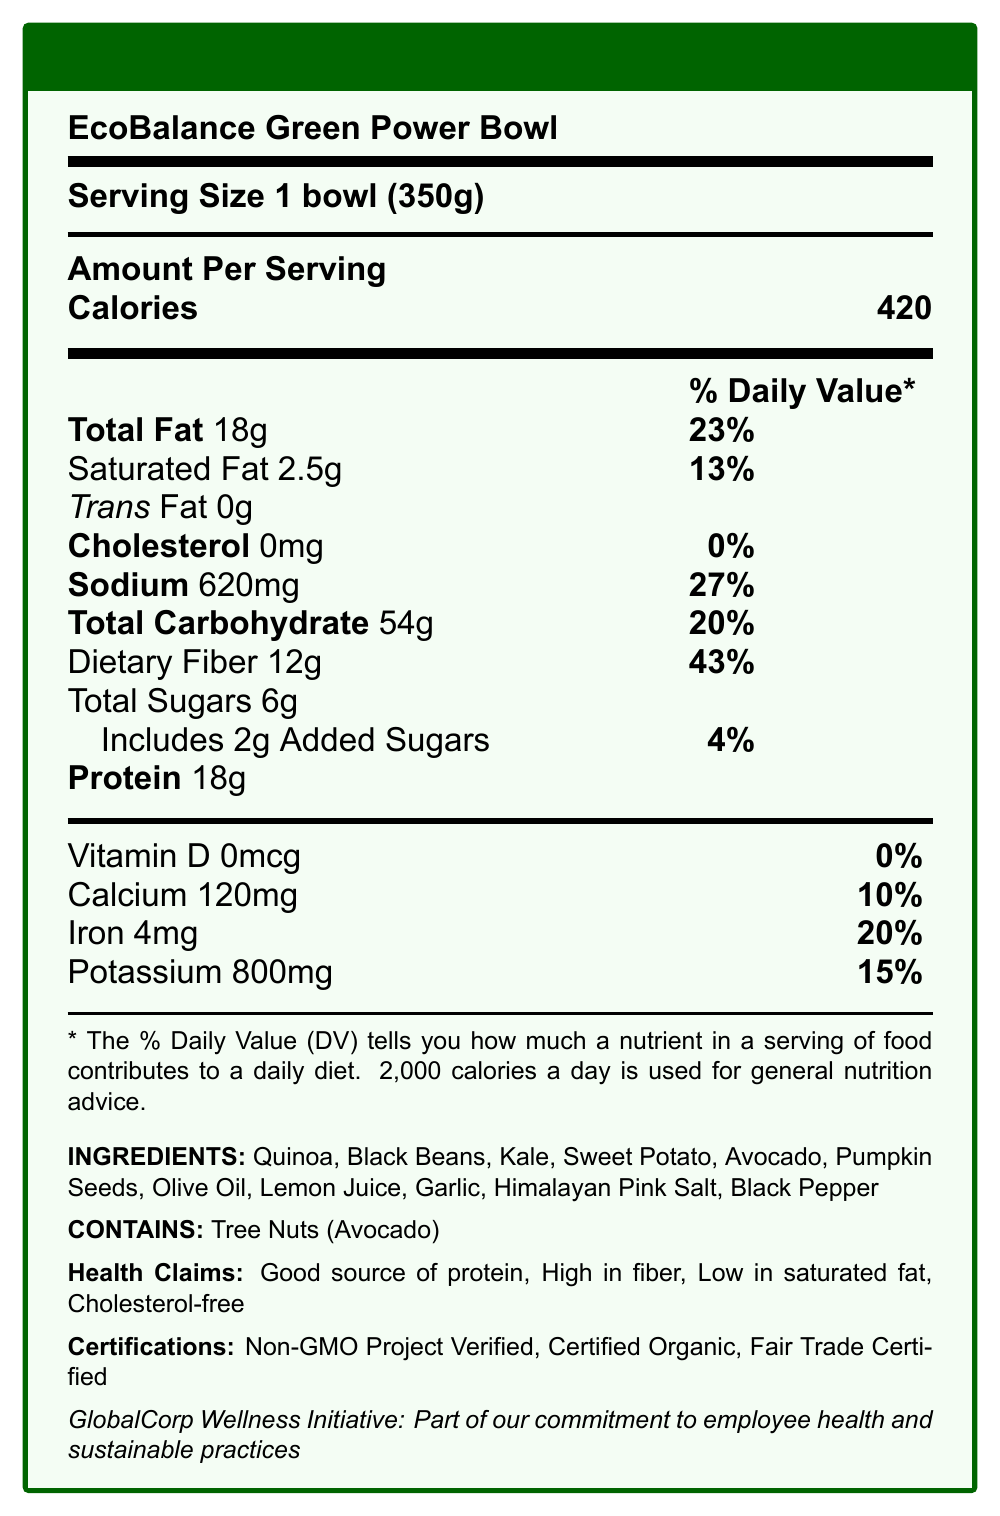what is the serving size for the EcoBalance Green Power Bowl? The serving size is explicitly mentioned as "1 bowl (350g)" in the document.
Answer: 1 bowl (350g) how many calories are there per serving? The document specifies that there are 420 calories per serving.
Answer: 420 calories what is the percentage of the daily value for sodium? The sodium content is given as 620mg, and it represents 27% of the daily value.
Answer: 27% what is the total fat content and its daily value percentage? The label shows that the total fat content is 18 grams, which is 23% of the daily value.
Answer: 18g, 23% which ingredient in the EcoBalance Green Power Bowl is a potential allergen? The document states that the bowl contains tree nuts (avocado), identified as a potential allergen.
Answer: Avocado (contains tree nuts) how much dietary fiber does one serving of the bowl provide? The dietary fiber content per serving is listed as 12 grams, which constitutes 43% of the daily value.
Answer: 12g, 43% what certifications does the EcoBalance Green Power Bowl have? A. Certified Organic B. Gluten-Free C. Fair Trade Certified D. Non-GMO Project Verified The certifications are mentioned as Non-GMO Project Verified, Certified Organic, and Fair Trade Certified.
Answer: A, C, D what is the total carbohydrate content and daily value percentage? A. 40g, 15% B. 54g, 20% C. 60g, 25% D. 48g, 18% The label indicates total carbohydrates of 54 grams, which is 20% of the daily value.
Answer: B. 54g, 20% is the EcoBalance Green Power Bowl cholesterol-free? The document specifies that the cholesterol content is 0mg and 0% of the daily value, indicating it is cholesterol-free.
Answer: Yes summarize the main idea of the document. The summary covers all the key sections such as serving size, calorie count, nutrients, ingredients, allergens, health claims, and certifications, highlighting them as part of an employee wellness initiative.
Answer: The document provides the Nutrition Facts for the EcoBalance Green Power Bowl, a plant-based meal option introduced as part of GlobalCorp’s employee wellness program. It highlights the serving size, calorie count, nutrient values, ingredients, potential allergens, health claims, and various certifications. what is the source of protein in the EcoBalance Green Power Bowl? The document lists multiple ingredients, but it does not specify which one is the source of the protein. Multiple ingredients like quinoa and black beans can contribute to the protein content.
Answer: Cannot be determined what daily value percentage does the calcium content of the EcoBalance Green Power Bowl provide? The label states that the calcium content is 120mg, contributing to 10% of the daily value.
Answer: 10% which health claims are made about the EcoBalance Green Power Bowl? The health claims section lists these specific claims of the product.
Answer: Good source of protein, High in fiber, Low in saturated fat, Cholesterol-free list the ingredients in the EcoBalance Green Power Bowl. The ingredients are explicitly listed in the document.
Answer: Quinoa, Black Beans, Kale, Sweet Potato, Avocado, Pumpkin Seeds, Olive Oil, Lemon Juice, Garlic, Himalayan Pink Salt, Black Pepper does the EcoBalance Green Power Bowl contain added sugars, and if so, how much? The document indicates that the bowl contains 6 grams of total sugars, with 2 grams of those being added sugars.
Answer: Yes, 2g added sugars 